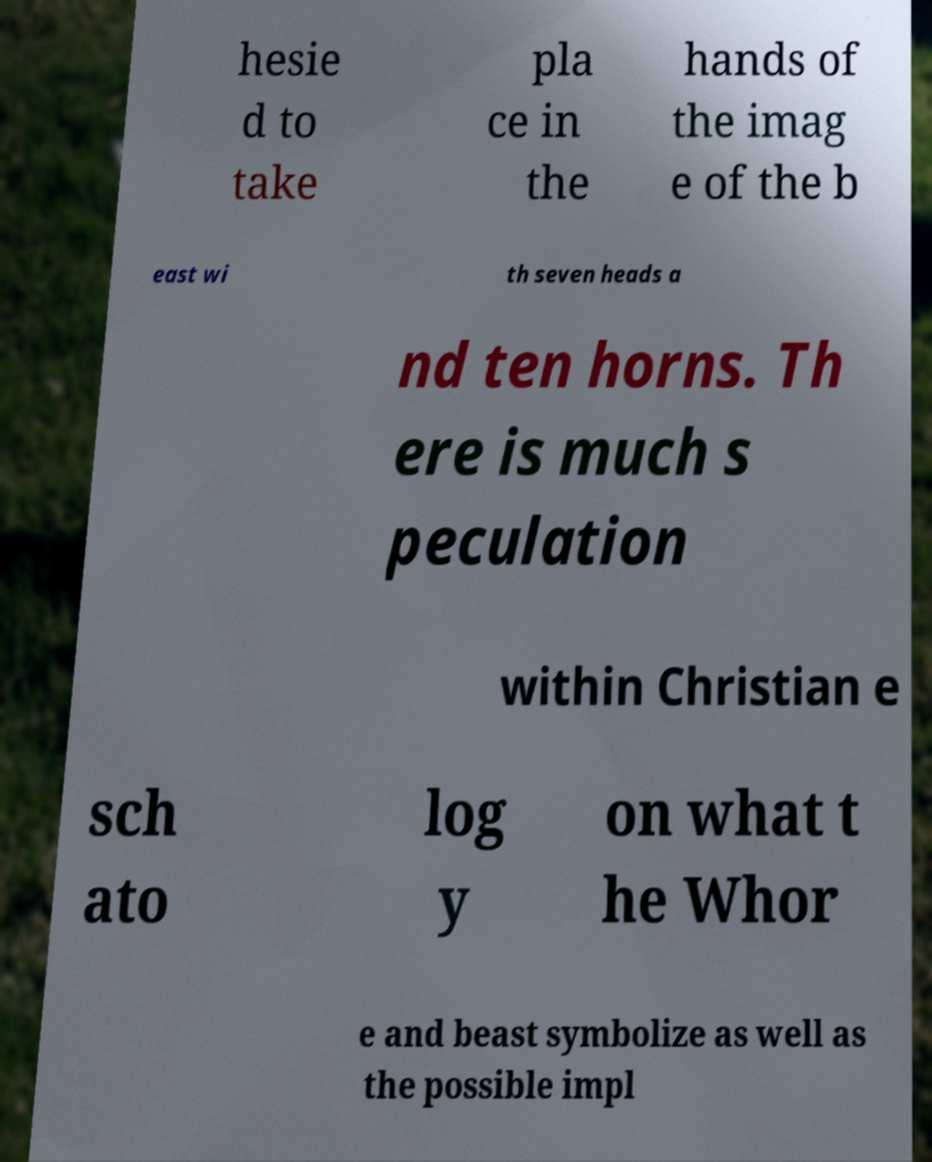Can you read and provide the text displayed in the image?This photo seems to have some interesting text. Can you extract and type it out for me? hesie d to take pla ce in the hands of the imag e of the b east wi th seven heads a nd ten horns. Th ere is much s peculation within Christian e sch ato log y on what t he Whor e and beast symbolize as well as the possible impl 